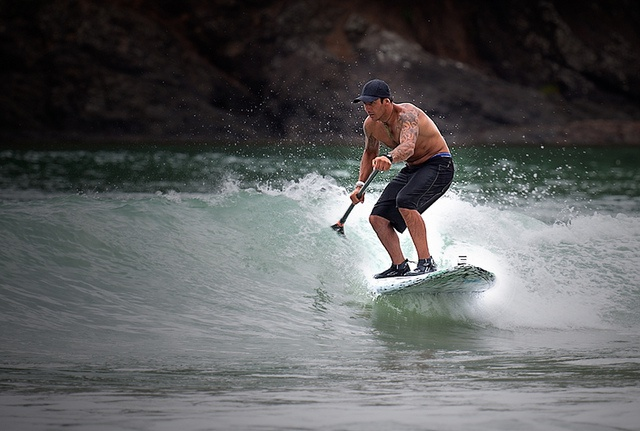Describe the objects in this image and their specific colors. I can see people in black, brown, maroon, and gray tones and surfboard in black, gray, white, and darkgray tones in this image. 